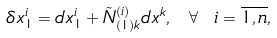<formula> <loc_0><loc_0><loc_500><loc_500>\delta x _ { 1 } ^ { i } = d x _ { 1 } ^ { i } + \tilde { N } _ { ( 1 ) k } ^ { ( i ) } d x ^ { k } , \text { } \forall \text { } i = \overline { 1 , n } ,</formula> 